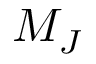Convert formula to latex. <formula><loc_0><loc_0><loc_500><loc_500>M _ { J }</formula> 